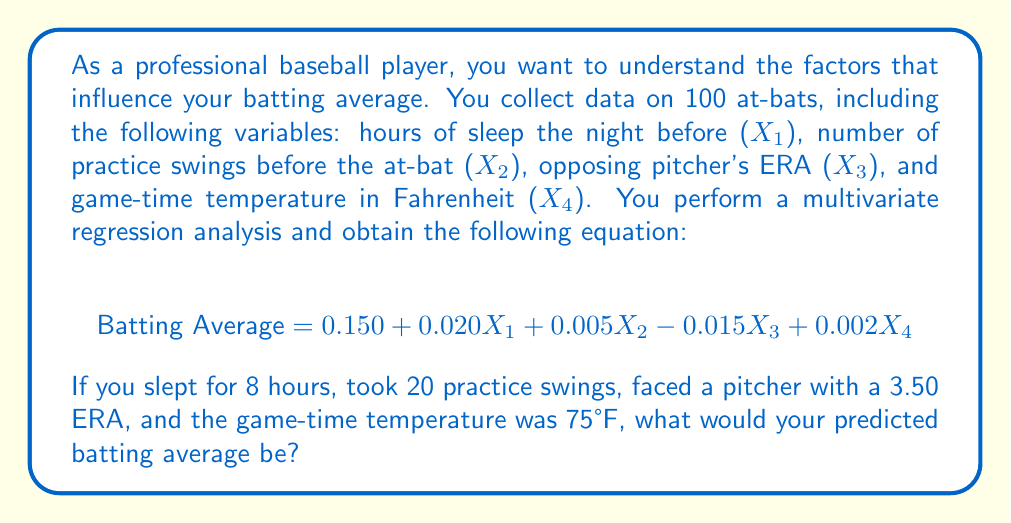Provide a solution to this math problem. To solve this problem, we need to use the multivariate regression equation provided and substitute the given values for each variable. Let's break it down step by step:

1. Identify the values for each variable:
   $X_1$ (hours of sleep) = 8
   $X_2$ (practice swings) = 20
   $X_3$ (pitcher's ERA) = 3.50
   $X_4$ (game-time temperature) = 75°F

2. Substitute these values into the equation:

   $$ \text{Batting Average} = 0.150 + 0.020X_1 + 0.005X_2 - 0.015X_3 + 0.002X_4 $$

3. Calculate each term:
   - Constant term: 0.150
   - Sleep term: $0.020 \times 8 = 0.160$
   - Practice swings term: $0.005 \times 20 = 0.100$
   - Pitcher's ERA term: $-0.015 \times 3.50 = -0.0525$
   - Temperature term: $0.002 \times 75 = 0.150$

4. Sum all the terms:
   $$ \text{Batting Average} = 0.150 + 0.160 + 0.100 - 0.0525 + 0.150 $$

5. Perform the final calculation:
   $$ \text{Batting Average} = 0.5075 $$

Therefore, under these conditions, your predicted batting average would be 0.5075, or rounded to three decimal places, 0.508.
Answer: 0.508 